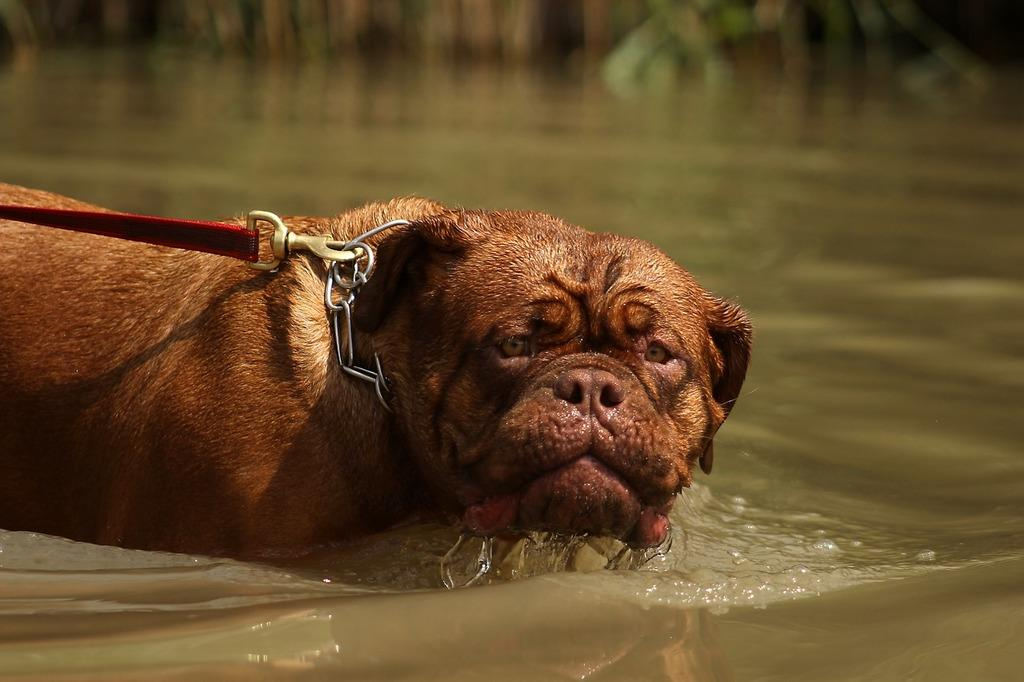What animal is present in the image? There is a dog in the image. Where is the dog located? The dog is in the water. Can you describe the background of the image? The background of the image is blurred. What type of button can be seen on the dog's collar in the image? There is no button visible on the dog's collar in the image. What type of creature is swimming with the dog in the image? There is no other creature swimming with the dog in the image. 